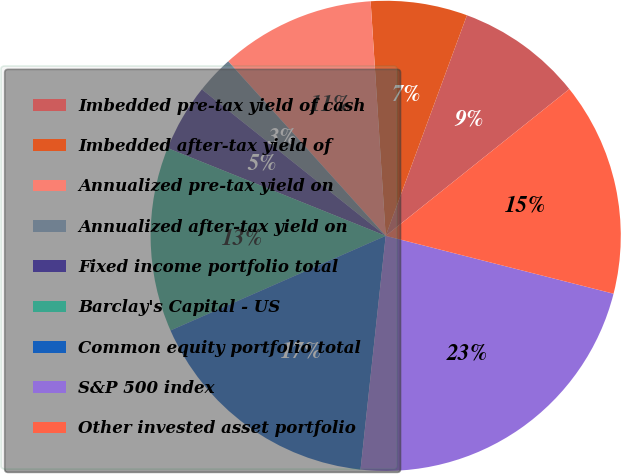Convert chart. <chart><loc_0><loc_0><loc_500><loc_500><pie_chart><fcel>Imbedded pre-tax yield of cash<fcel>Imbedded after-tax yield of<fcel>Annualized pre-tax yield on<fcel>Annualized after-tax yield on<fcel>Fixed income portfolio total<fcel>Barclay's Capital - US<fcel>Common equity portfolio total<fcel>S&P 500 index<fcel>Other invested asset portfolio<nl><fcel>8.65%<fcel>6.64%<fcel>10.66%<fcel>2.61%<fcel>4.62%<fcel>12.68%<fcel>16.7%<fcel>22.75%<fcel>14.69%<nl></chart> 